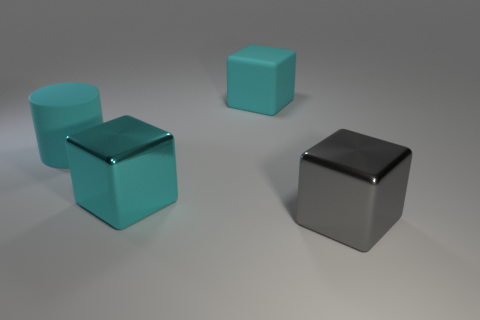Is the number of shiny objects that are right of the big cyan metal object less than the number of cyan rubber objects behind the gray cube?
Make the answer very short. Yes. There is a big thing that is both in front of the large cylinder and on the left side of the gray cube; what shape is it?
Keep it short and to the point. Cube. There is a matte cylinder; does it have the same color as the cube that is behind the cyan shiny cube?
Provide a succinct answer. Yes. What is the object that is to the left of the big matte cube and right of the big rubber cylinder made of?
Ensure brevity in your answer.  Metal. What is the size of the metallic block that is the same color as the cylinder?
Provide a short and direct response. Large. Does the large metal object that is behind the big gray metal thing have the same shape as the cyan matte object behind the large matte cylinder?
Give a very brief answer. Yes. Is there a purple metal cylinder?
Make the answer very short. No. The other large metallic thing that is the same shape as the gray shiny object is what color?
Provide a succinct answer. Cyan. What color is the rubber cylinder that is the same size as the cyan metallic block?
Offer a terse response. Cyan. How many rubber things have the same color as the big matte cube?
Make the answer very short. 1. 